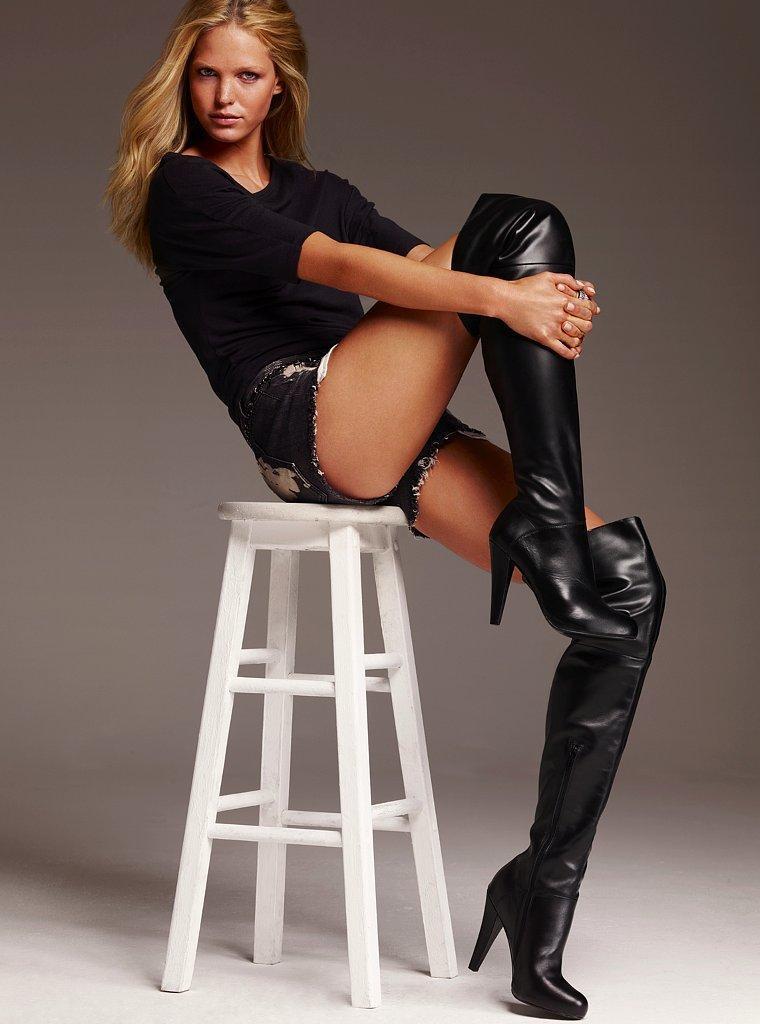How would you summarize this image in a sentence or two? In this image I can see a woman wearing black colored dress and black boots is sitting on the white colored stool. I can see the white colored floor. 